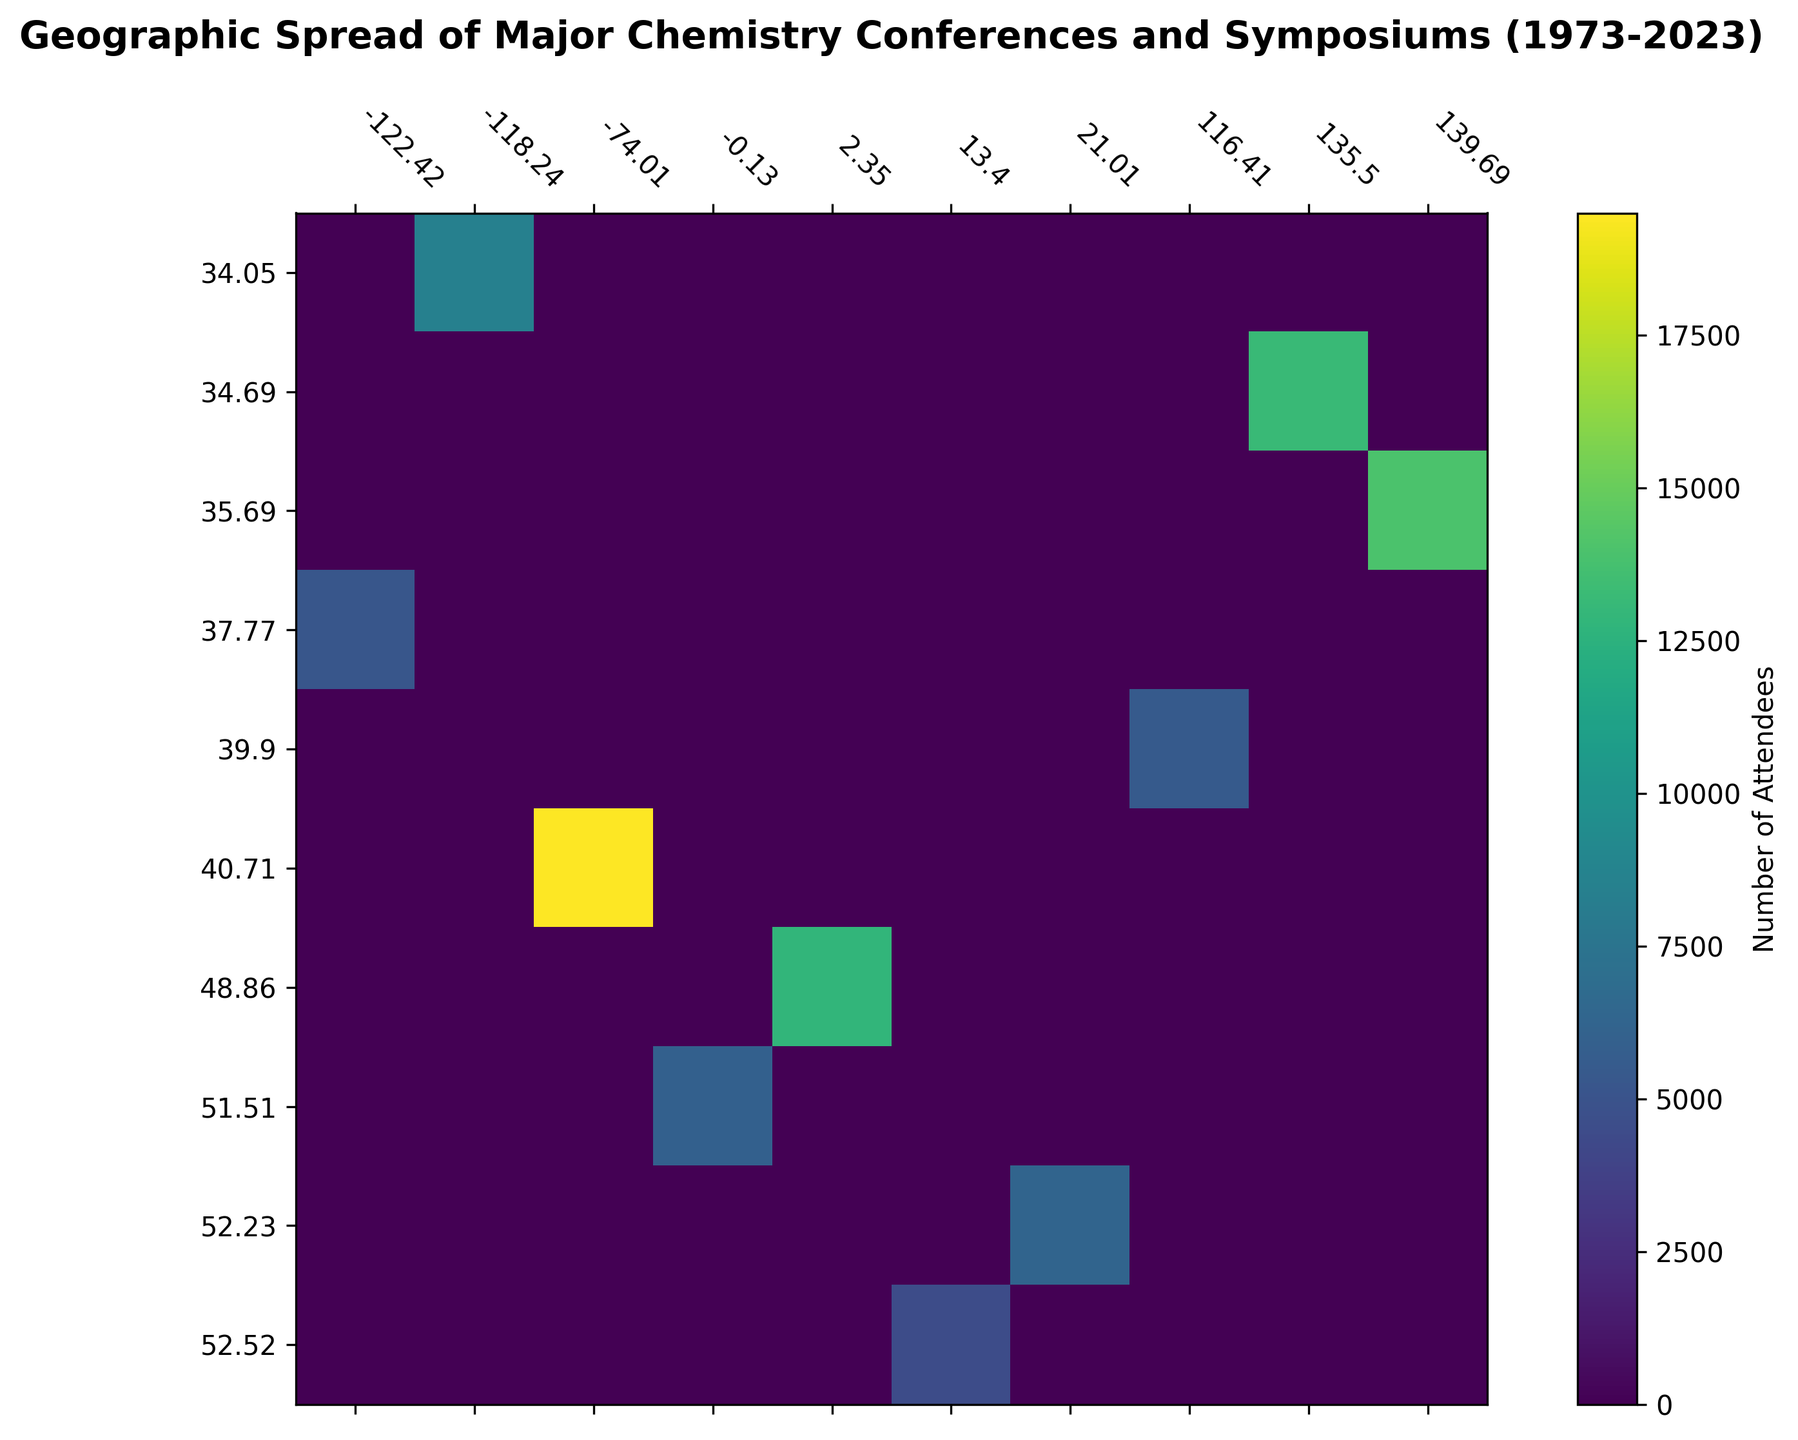What's the location with the highest number of attendees? The darkest colored cell represents the highest number of attendees. Based on the heatmap, locate the darkest cell to find the corresponding latitude and longitude.
Answer: 34.6937, 135.5023 (Osaka, Japan) Which year had the most attendees at a conference in New York? Find the cell corresponding to New York's latitude (40.7128) and longitude (-74.0060) and identify the year with the highest attendee count for that location.
Answer: 2022 Compare the number of attendees in the Pacifichem conference in 1995 with 2015. Which year had more attendees? Locate the cells corresponding to Pacifichem conferences and compare the attendee counts for the years 1995 and 2015.
Answer: 2015 Identify the location and year for the RSC International Symposium with the largest attendance. Review the heatmap for cells tagged with the RSC International Symposium and identify the one with the highest attendance, then refer to the year for that data point.
Answer: 1990, Paris Sum the total number of attendees for all ACS National Meeting & Exposition conferences shown on the heatmap. Locate all instances of the ACS National Meeting & Exposition on the heatmap. Sum the attendee counts for 1973, 2000, and 2022. The calculation involves adding 5000, 4500, and 7000.
Answer: 16500 Which event had more attendees, the IUPAC World Chemistry Congress in 1985 or the EuroChem Congress in 2017? Compare the colors or numbers of attendees for the specified events.
Answer: IUPAC World Chemistry Congress, 1985 What is the average number of attendees for the International Symposiums organized by RSC? Locate all RSC International Symposium events and sum their attendees, then divide by the number of events to find the average. Specific events include 1980, 1990, 2010, and 2020. Add 6000, 7000, 5000, 6300 and divide by 4.
Answer: 6075 Were there any conferences in Europe during the 1980s? If so, what were the locations? Check the heatmap for any cells corresponding to European coordinates (e.g., London, Paris, Berlin) during the 1980s and list the locations.
Answer: 1980: London Compare the geographical spread of the conferences over the decades. Which continent hosted the most conferences? Visually assess the density and color intensity of the heatmap cells across decades for each continent. Count the number of events per continent to identify the most frequent host continent.
Answer: Asia What is the difference in the number of attendees between the ACS National Meeting & Exposition in 1973 and 2022? Find the cells corresponding to the ACS National Meeting & Exposition for 1973 and 2022. Subtract the number from 1973 (5000) from 2022 (7000) to find the difference.
Answer: 2000 